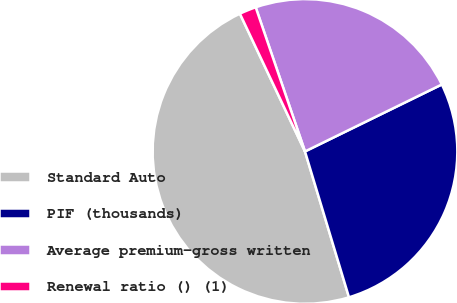Convert chart to OTSL. <chart><loc_0><loc_0><loc_500><loc_500><pie_chart><fcel>Standard Auto<fcel>PIF (thousands)<fcel>Average premium-gross written<fcel>Renewal ratio () (1)<nl><fcel>47.64%<fcel>27.58%<fcel>23.0%<fcel>1.78%<nl></chart> 